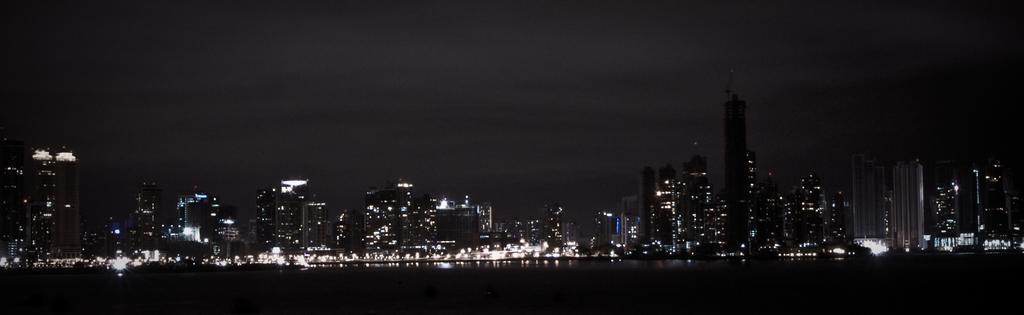Can you describe this image briefly? In this image I can see number of buildings and number of lights. I can also see this image is in dark. 